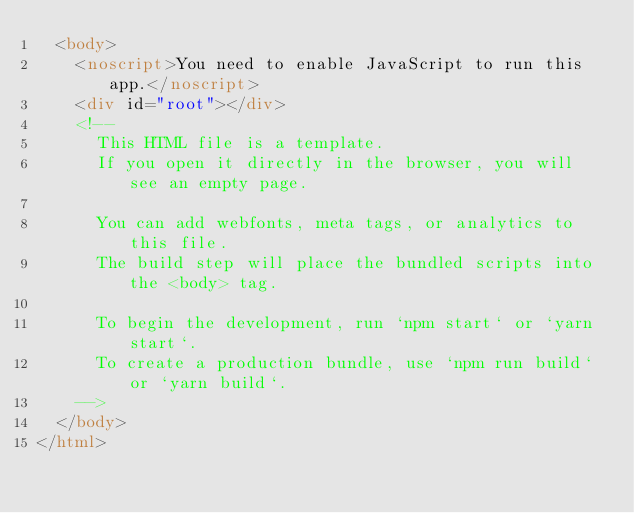Convert code to text. <code><loc_0><loc_0><loc_500><loc_500><_HTML_>  <body>
    <noscript>You need to enable JavaScript to run this app.</noscript>
    <div id="root"></div>
    <!--
      This HTML file is a template.
      If you open it directly in the browser, you will see an empty page.

      You can add webfonts, meta tags, or analytics to this file.
      The build step will place the bundled scripts into the <body> tag.

      To begin the development, run `npm start` or `yarn start`.
      To create a production bundle, use `npm run build` or `yarn build`.
    -->
  </body>
</html>
</code> 